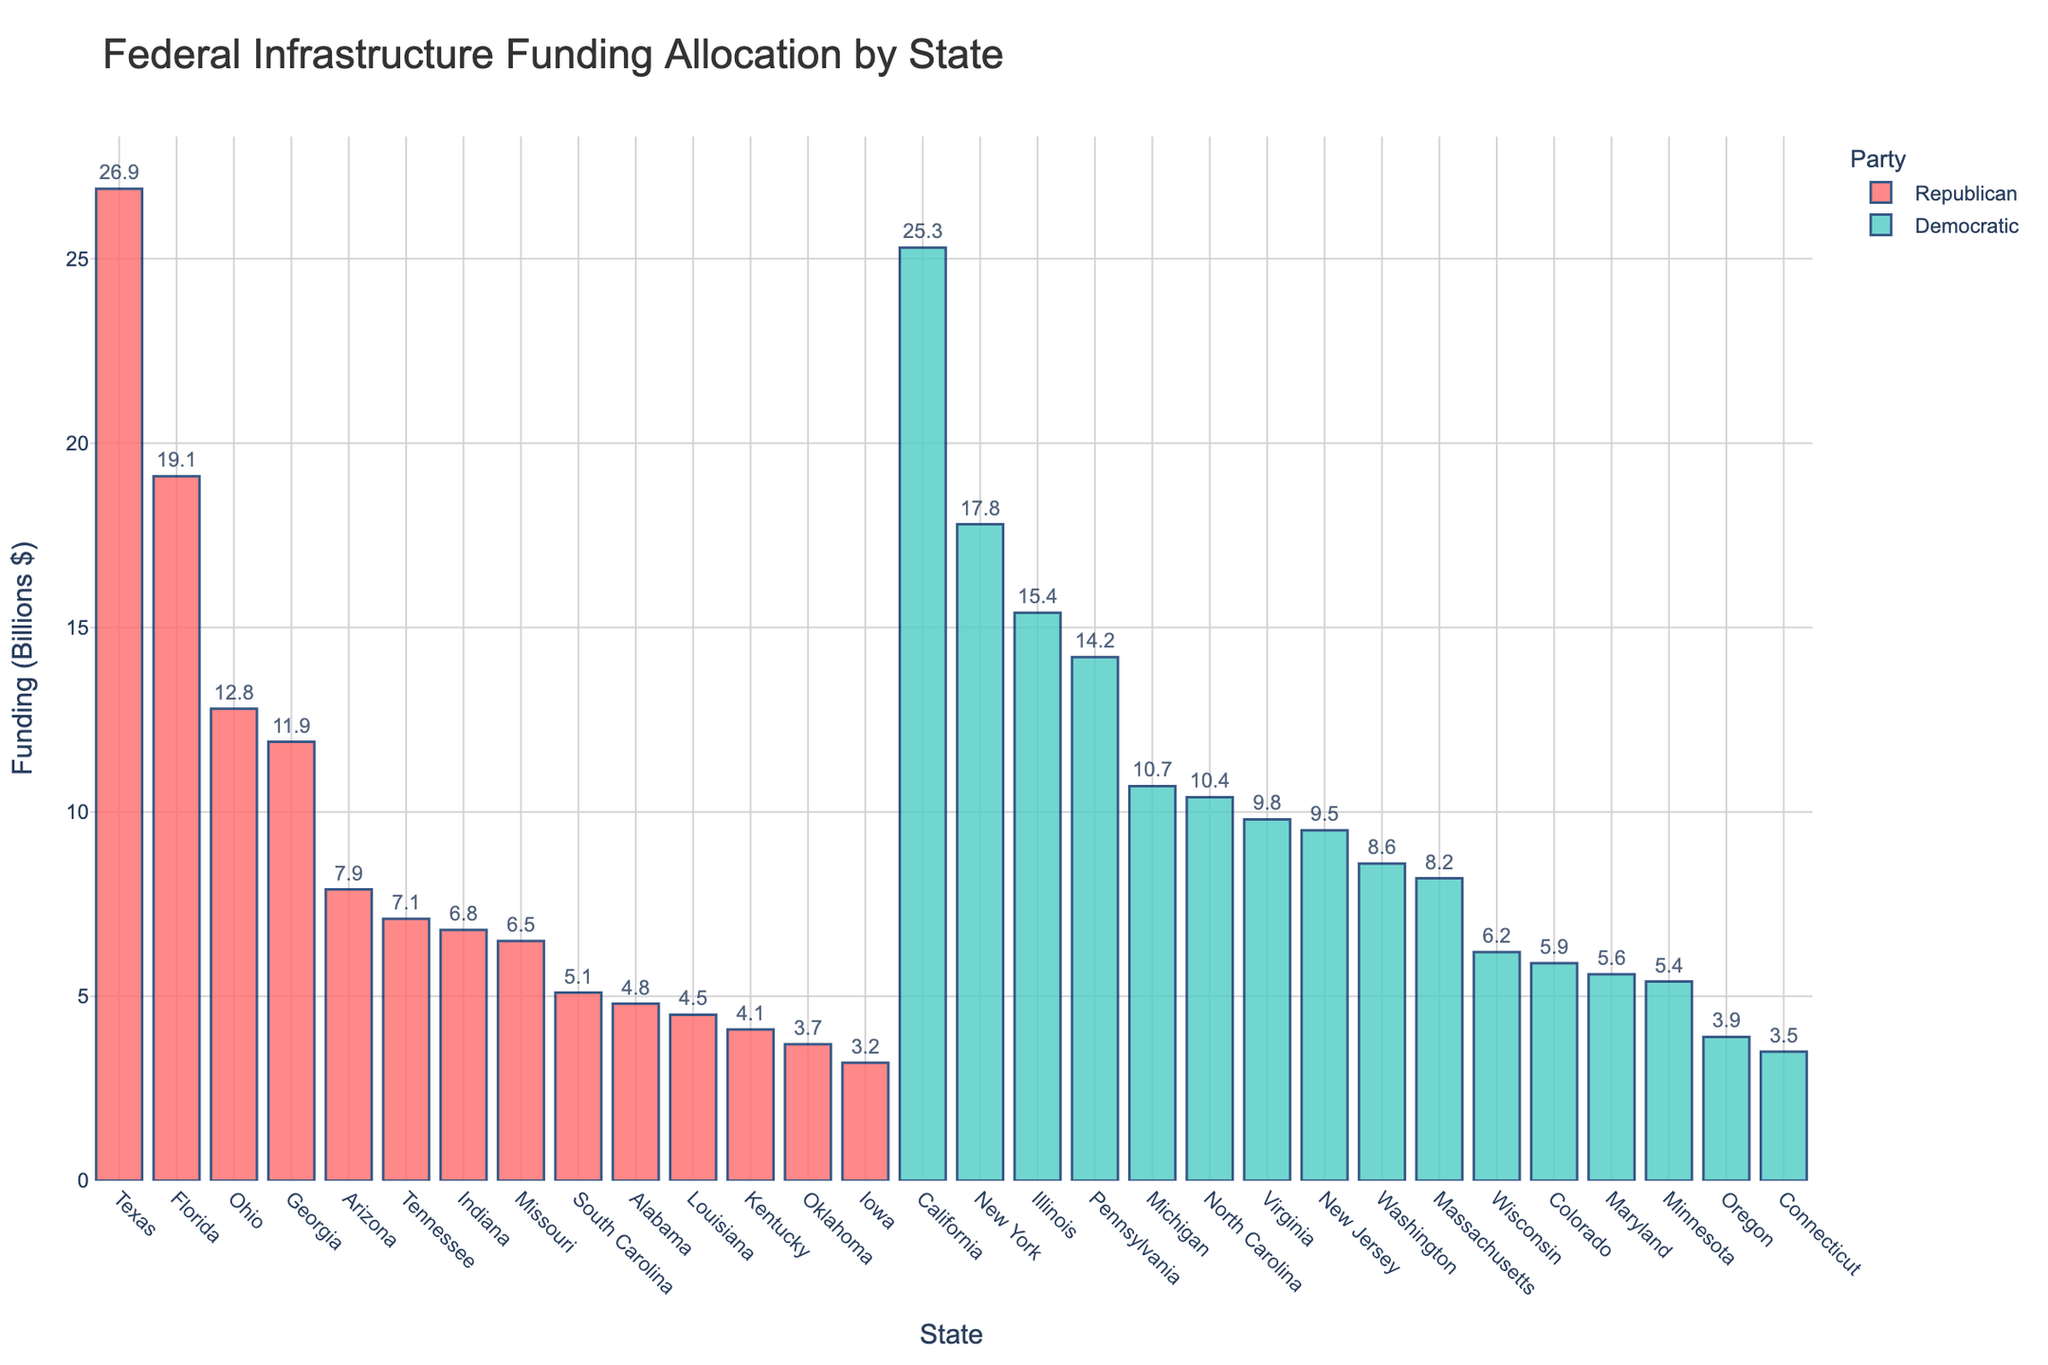Which state received the highest federal funding for infrastructure projects? The highest bar corresponds to Texas, indicating it received the most funding.
Answer: Texas Which party's states received more federal funding on average? First, sum up the total funding for Democratic and Republican states, then divide by the number of states for each party. Democratic: (25.3 + 17.8 + 15.4 + 14.2 + 10.7 + 10.4 + 9.8 + 9.5 + 8.6 + 8.2 + 6.2 + 5.9 + 5.6 + 5.4 + 3.9 + 3.5) / 16 = 153.4 / 16 = 9.6. Republican: (26.9 + 19.1 + 12.8 + 11.9 + 7.9 + 7.1 + 6.8 + 6.5 + 5.1 + 4.8 + 4.5 + 4.1 + 3.7 + 3.2) / 14 = 124.4 / 14 = 8.9. Democratic states received more on average.
Answer: Democratic What is the total federal funding allocated to Republican-led states? Sum the funding for all Republican-led states: 26.9 + 19.1 + 12.8 + 11.9 + 7.9 + 7.1 + 6.8 + 6.5 + 5.1 + 4.8 + 4.5 + 4.1 + 3.7 + 3.2 = 124.4 billion dollars
Answer: 124.4 billion dollars Which state has a similar level of funding to Ohio? Comparing the heights of the bars and the data values, Georgia is the state with funding (11.9 billion) closest to Ohio (12.8 billion).
Answer: Georgia How does the funding for Pennsylvania compare to that for Ohio and Virginia combined? Pennsylvania received 14.2 billion dollars. Ohio and Virginia together received 12.8 + 9.8 = 22.6 billion dollars. Pennsylvania's funding is less (14.2 < 22.6).
Answer: Less Which state received more funding: Michigan or North Carolina? By comparing the heights of the bars and checking the data values: Michigan received 10.7 billion dollars and North Carolina received 10.4 billion dollars.
Answer: Michigan What is the difference in funding between California and Florida? Subtract Florida's funding from California's funding: 25.3 - 19.1 = 6.2 billion dollars
Answer: 6.2 billion dollars What is the average infrastructure funding for the top five funded states? Sum the top five's funding (Texas, California, Florida, New York, Illinois): 26.9 + 25.3 + 19.1 + 17.8 + 15.4 = 104.5 billion dollars. Divide by 5: 104.5 / 5 = 20.9 billion dollars
Answer: 20.9 billion dollars Which state received the least amount of infrastructure funding? The shortest bar corresponds to Iowa, indicating it received the least funding.
Answer: Iowa 